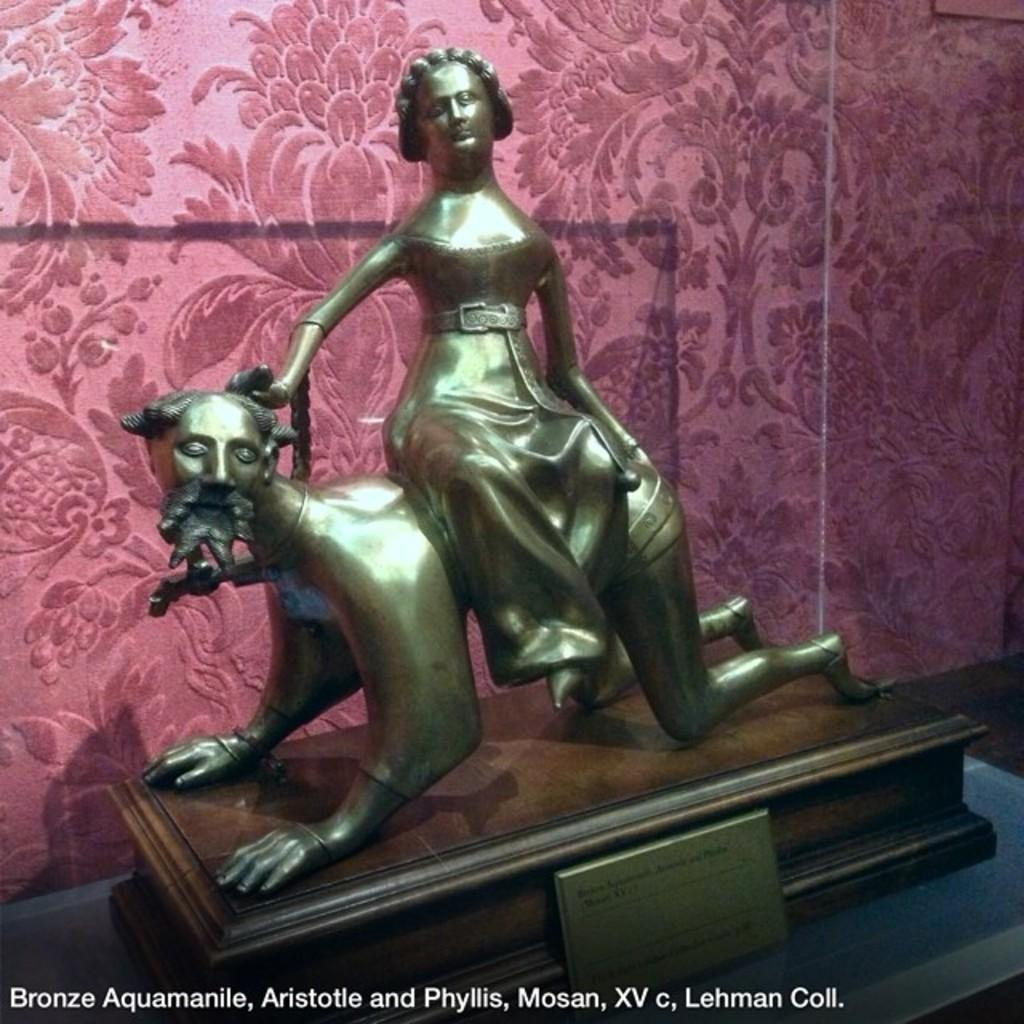How many statues are present in the image? There are two statues in the image. What is the color of the statues? The statues are gold in color. What can be seen in the background of the image? There is a maroon color sheet in the background of the image. What type of trousers are the statues wearing in the image? The statues are statues, and therefore they do not wear trousers or any clothing. --- 